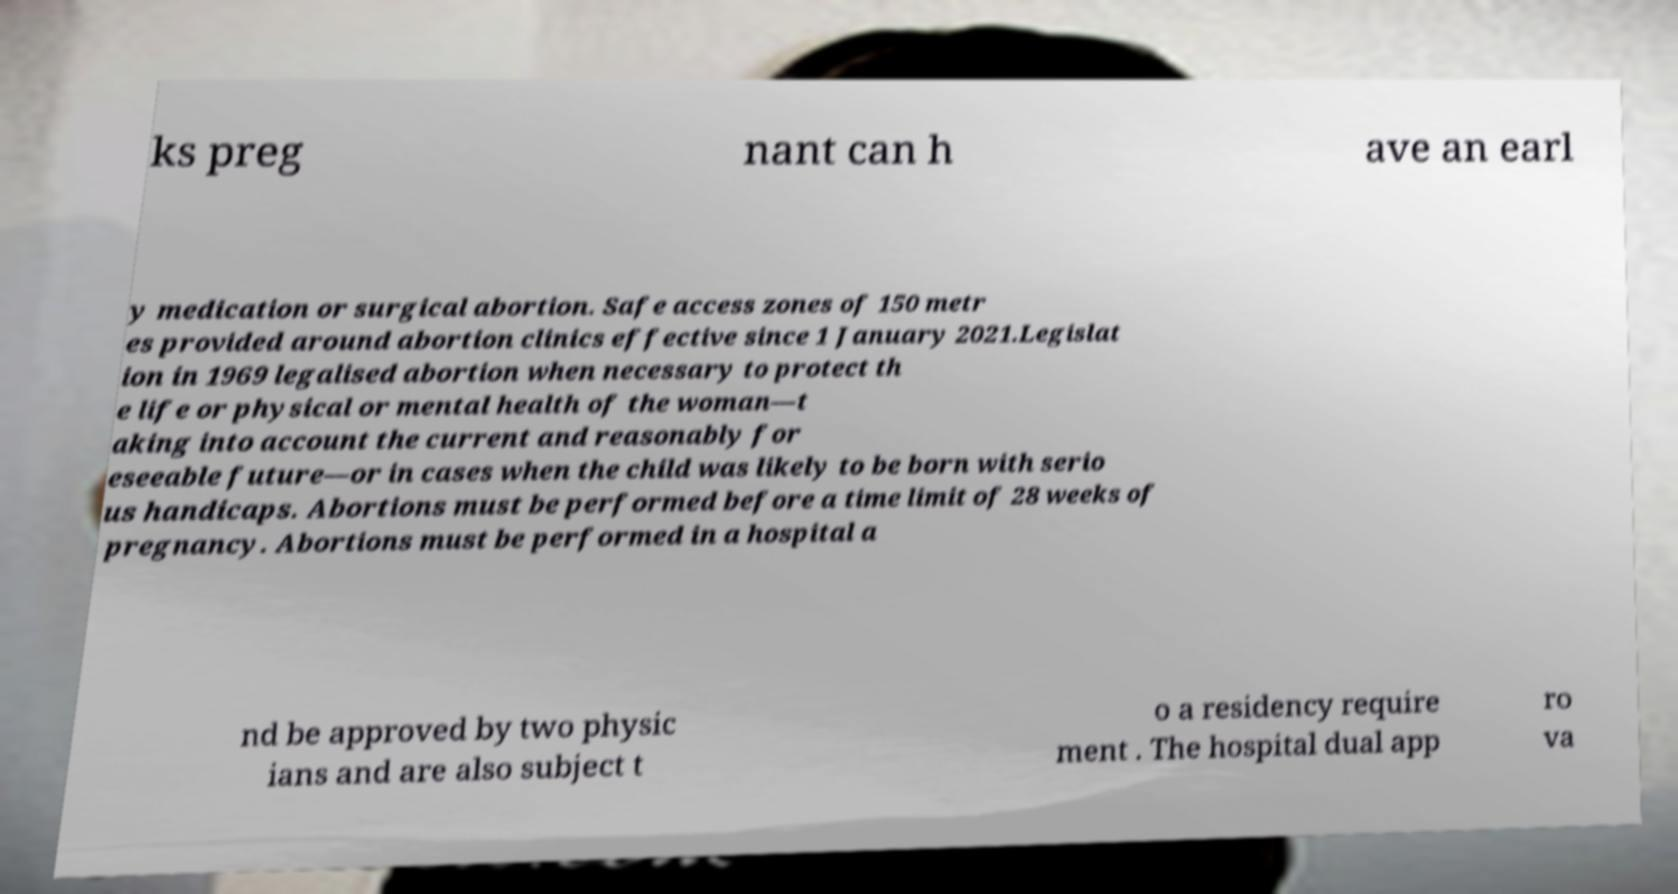What messages or text are displayed in this image? I need them in a readable, typed format. ks preg nant can h ave an earl y medication or surgical abortion. Safe access zones of 150 metr es provided around abortion clinics effective since 1 January 2021.Legislat ion in 1969 legalised abortion when necessary to protect th e life or physical or mental health of the woman—t aking into account the current and reasonably for eseeable future—or in cases when the child was likely to be born with serio us handicaps. Abortions must be performed before a time limit of 28 weeks of pregnancy. Abortions must be performed in a hospital a nd be approved by two physic ians and are also subject t o a residency require ment . The hospital dual app ro va 